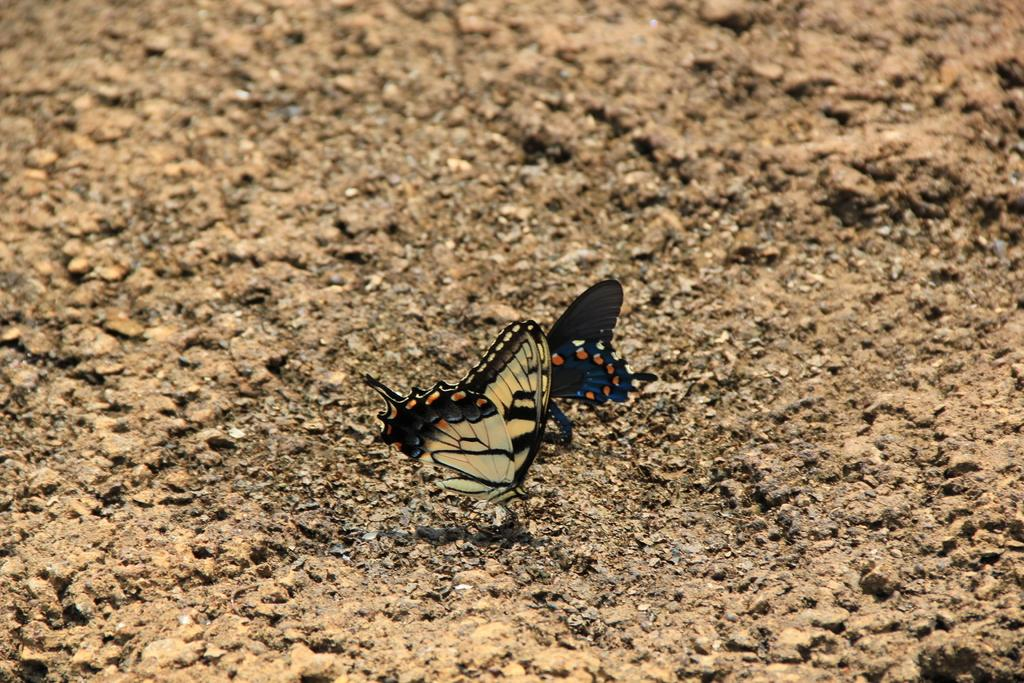How many butterflies are present in the image? There are two butterflies in the image. Where are the butterflies located? The butterflies are on a land. What type of education system is being discussed in the image? There is no discussion of an education system in the image, as it features two butterflies on a land. 